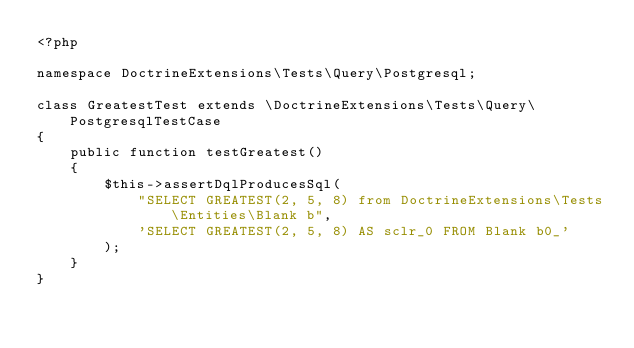Convert code to text. <code><loc_0><loc_0><loc_500><loc_500><_PHP_><?php

namespace DoctrineExtensions\Tests\Query\Postgresql;

class GreatestTest extends \DoctrineExtensions\Tests\Query\PostgresqlTestCase
{
    public function testGreatest()
    {
        $this->assertDqlProducesSql(
            "SELECT GREATEST(2, 5, 8) from DoctrineExtensions\Tests\Entities\Blank b",
            'SELECT GREATEST(2, 5, 8) AS sclr_0 FROM Blank b0_'
        );
    }
}
</code> 